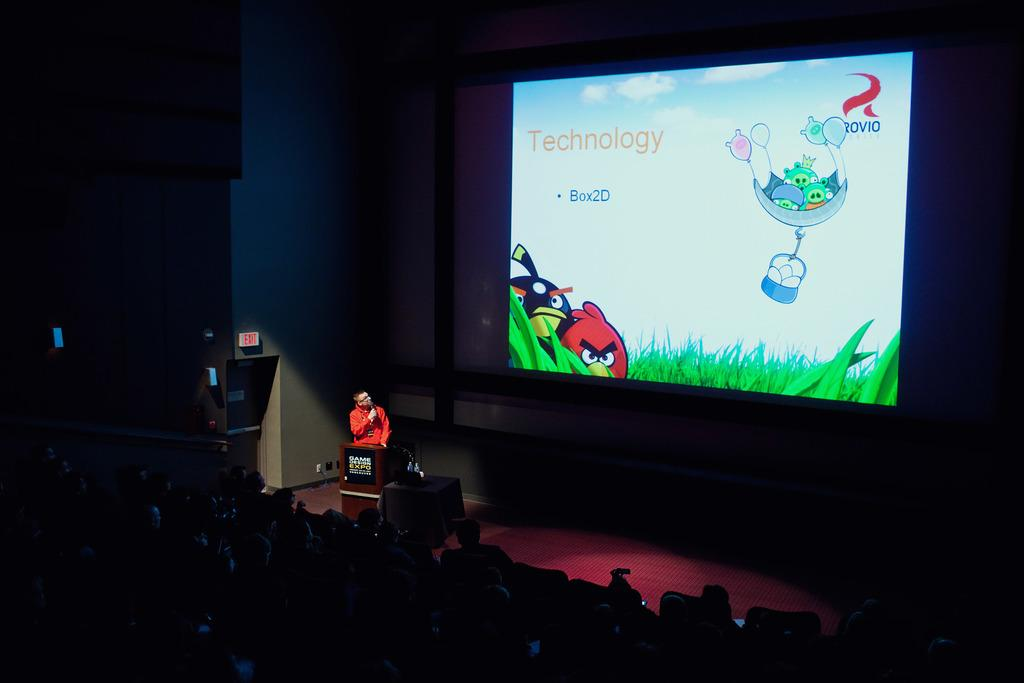<image>
Render a clear and concise summary of the photo. A man speaks at the game design expo with Angry Birds in the background. 